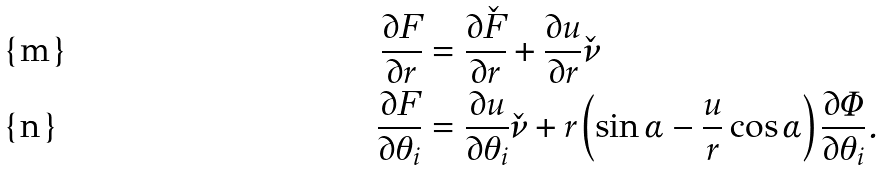<formula> <loc_0><loc_0><loc_500><loc_500>\frac { \partial F } { \partial r } & = \frac { \partial \check { F } } { \partial r } + \frac { \partial u } { \partial r } \check { \nu } \\ \frac { \partial F } { \partial \theta _ { i } } & = \frac { \partial u } { \partial \theta _ { i } } \check { \nu } + r \left ( \sin \alpha - \frac { u } { r } \cos \alpha \right ) \frac { \partial \Phi } { \partial \theta _ { i } } .</formula> 